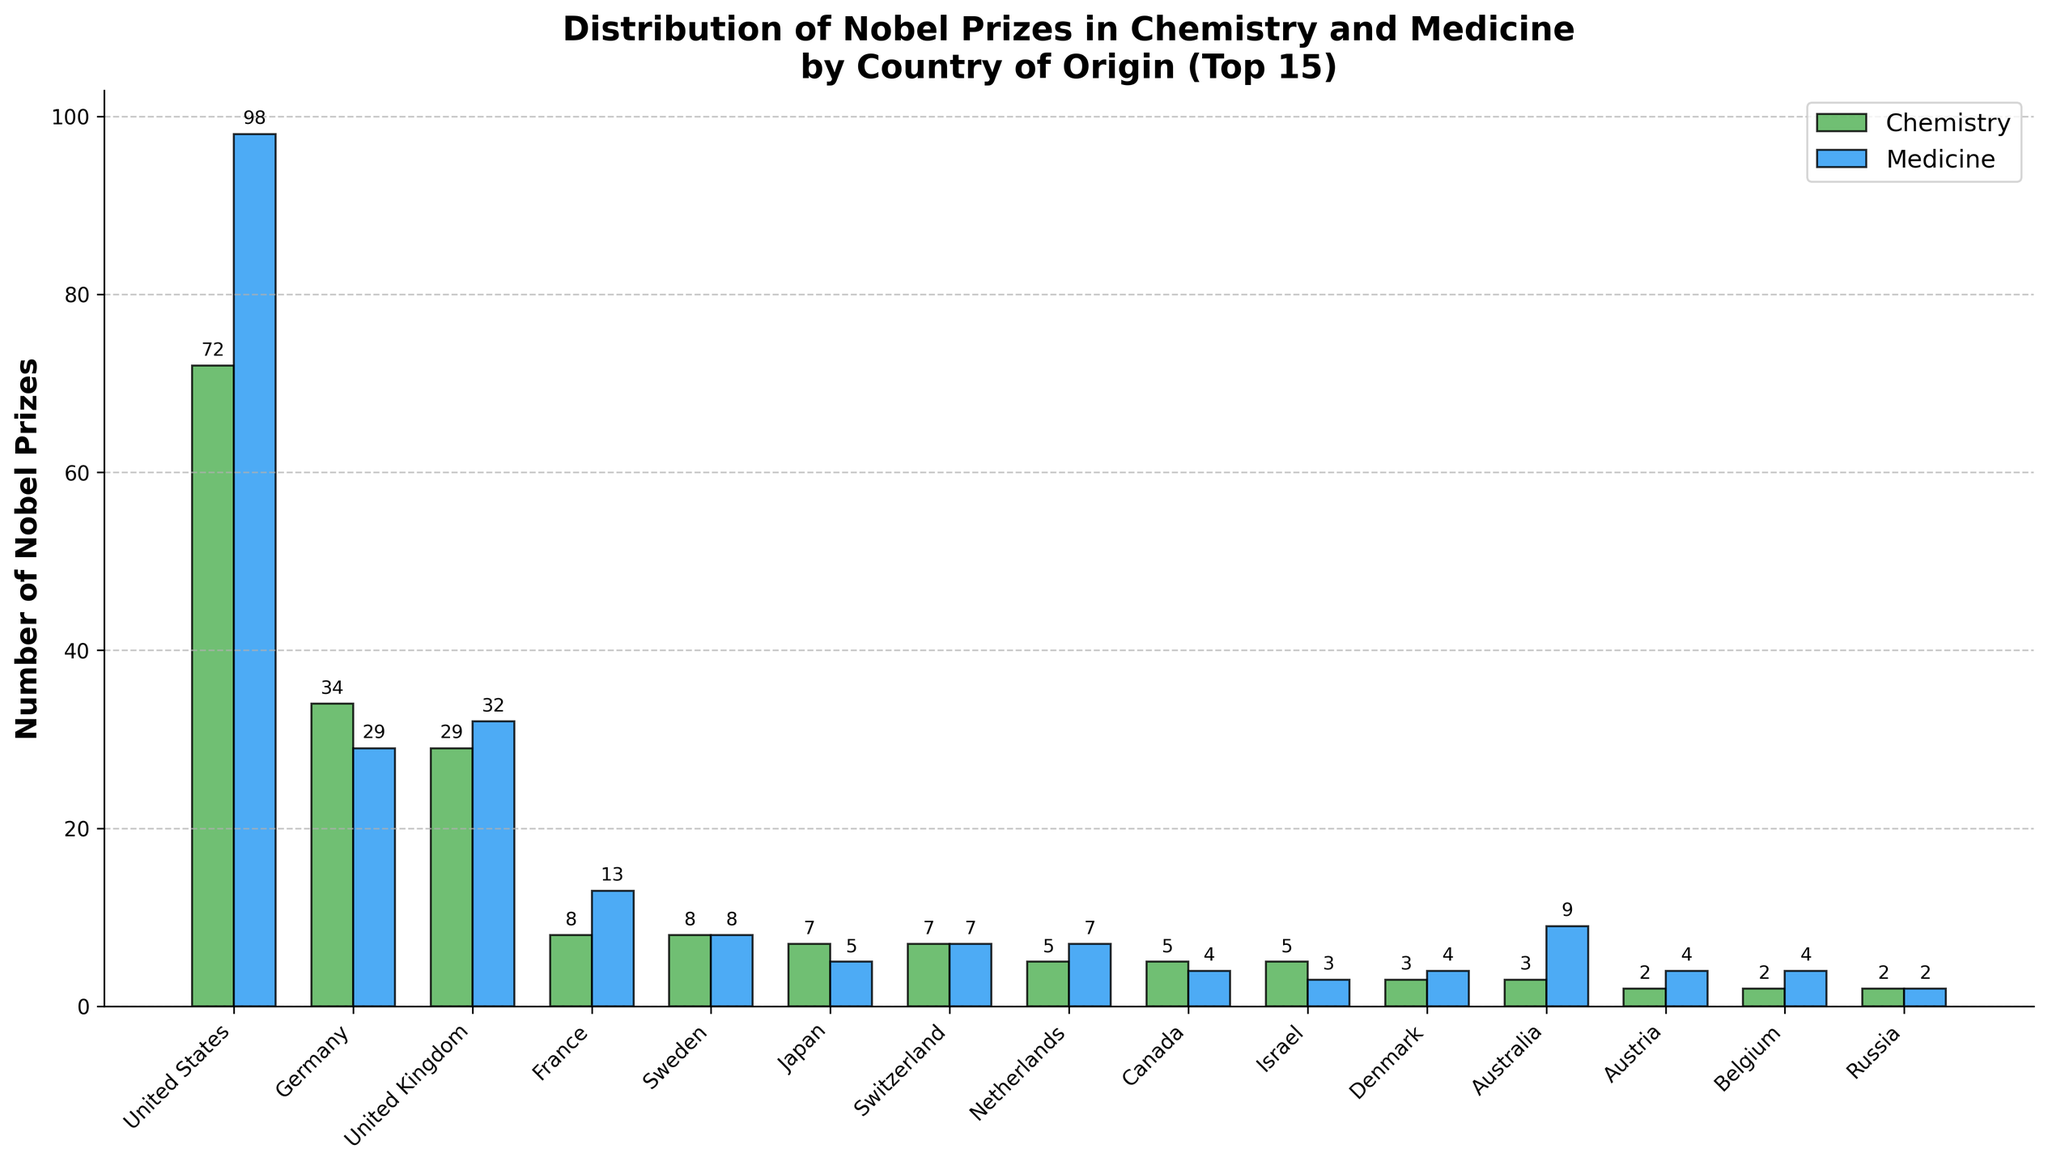Which country has won the highest number of Nobel Prizes in Medicine? By looking at the height of the bars in the Medicine category, the United States has the highest bar, indicating it has won the most Nobel Prizes in Medicine.
Answer: United States Which two countries have won an equal number of Nobel Prizes in Chemistry? By examining the heights of the Chemistry bars, Sweden and France both have bars of the same height, indicating they have each won 8 Nobel Prizes in Chemistry.
Answer: Sweden and France How many more Nobel Prizes in Medicine has the United Kingdom won compared to Chemistry? The United Kingdom has 32 Nobel Prizes in Medicine and 29 in Chemistry. The difference is calculated as 32 - 29 = 3.
Answer: 3 What is the combined total of Nobel Prizes in Chemistry for Germany, the United Kingdom, and Japan? Germany has 34, the United Kingdom has 29, and Japan has 7 Nobel Prizes in Chemistry. Adding these together: 34 + 29 + 7 = 70.
Answer: 70 Which country among the top 15 has won the least number of Nobel Prizes in Medicine? By comparing the heights of the Medicine bars for the top 15 countries, Israel has the lowest bar with only 3 Nobel Prizes won.
Answer: Israel What is the total number of Nobel Prizes won by Australia across both categories? Australia has 3 Nobel Prizes in Chemistry and 9 in Medicine. Summing these gives 3 + 9 = 12.
Answer: 12 Which country has more Nobel Prizes in Medicine than in Chemistry, Sweden or Switzerland? Switzerland has 7 Nobel Prizes in both categories. Sweden also has 8 Nobel Prizes in both categories, indicating neither has more in Medicine than Chemistry.
Answer: Neither How does the number of Nobel Prizes in Medicine for Canada compare to that in Chemistry? Canada has 4 Nobel Prizes in Medicine and 5 in Chemistry, so it has one fewer Nobel Prize in Medicine compared to Chemistry.
Answer: One fewer in Medicine What is the ratio of Nobel Prizes in Chemistry to Medicine for France? France has 8 Nobel Prizes in Chemistry and 13 in Medicine. The ratio is calculated as 8:13.
Answer: 8:13 Which country within the top 15 has the smallest difference between Nobel Prizes in Chemistry and Medicine? Switzerland has equal numbers of Nobel Prizes in Chemistry and Medicine, making the difference 0.
Answer: Switzerland 